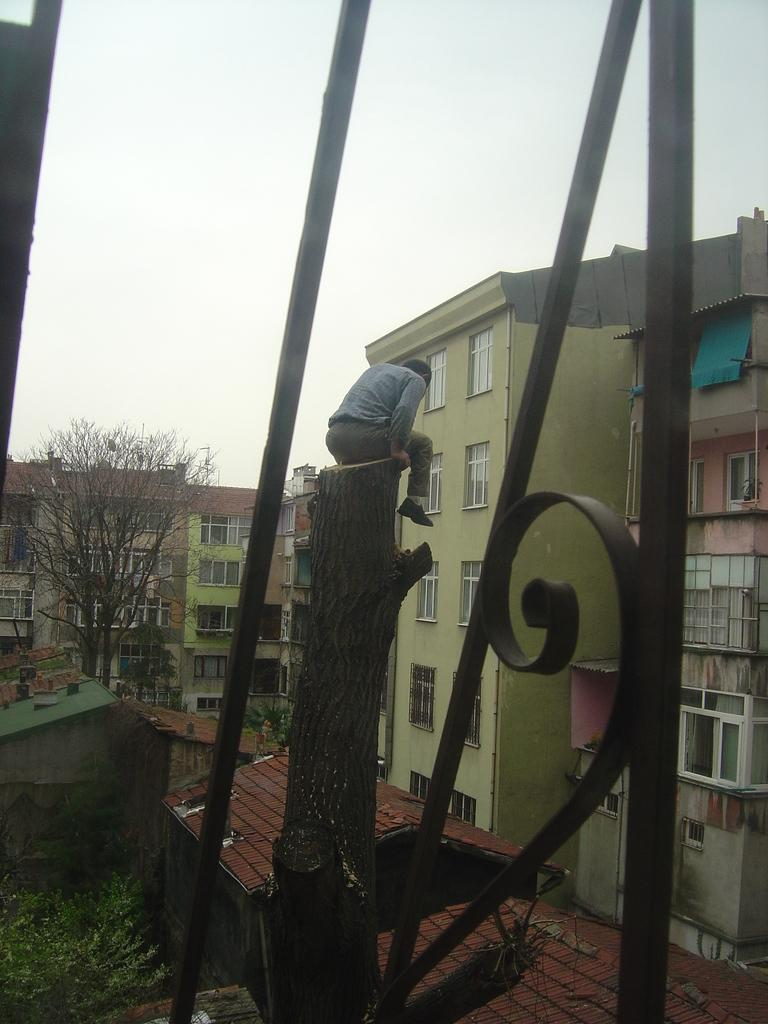What objects are made of iron in the image? There are iron rods in the image. What is the man in the image doing? The man is sitting on a log in the image. What type of structures can be seen in the background of the image? There are buildings and houses in the background of the image. What natural element is present in the background of the image? There is a tree in the background of the image. What part of the natural environment is visible in the image? The sky is visible in the background of the image. What type of knowledge is the man gaining during the recess in the image? There is no recess or indication of gaining knowledge in the image; the man is simply sitting on a log. What type of iron is the man using to create a sculpture in the image? There is no sculpture or iron being used for sculpting in the image; only iron rods are present. 